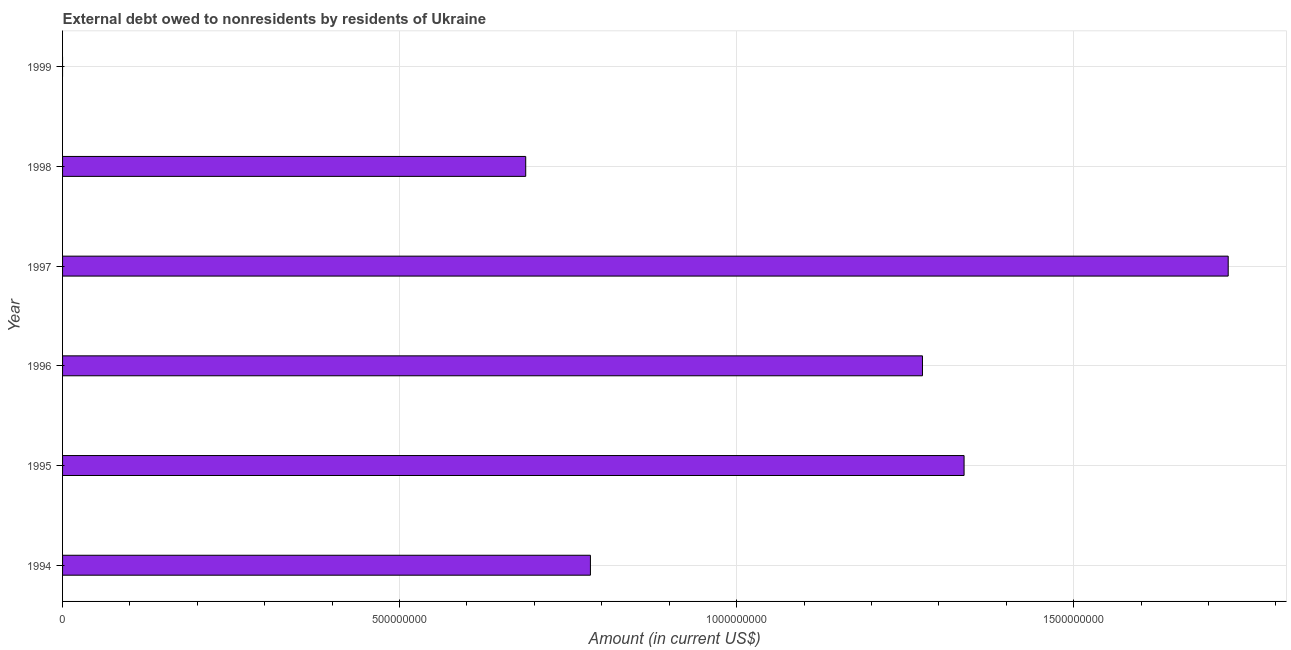What is the title of the graph?
Make the answer very short. External debt owed to nonresidents by residents of Ukraine. What is the label or title of the X-axis?
Offer a terse response. Amount (in current US$). What is the label or title of the Y-axis?
Provide a succinct answer. Year. What is the debt in 1995?
Ensure brevity in your answer.  1.34e+09. Across all years, what is the maximum debt?
Your response must be concise. 1.73e+09. In which year was the debt maximum?
Your answer should be very brief. 1997. What is the sum of the debt?
Keep it short and to the point. 5.81e+09. What is the difference between the debt in 1995 and 1996?
Your answer should be very brief. 6.17e+07. What is the average debt per year?
Offer a very short reply. 9.69e+08. What is the median debt?
Offer a very short reply. 1.03e+09. What is the ratio of the debt in 1996 to that in 1997?
Offer a very short reply. 0.74. Is the debt in 1995 less than that in 1996?
Your answer should be compact. No. What is the difference between the highest and the second highest debt?
Give a very brief answer. 3.92e+08. Is the sum of the debt in 1994 and 1998 greater than the maximum debt across all years?
Offer a terse response. No. What is the difference between the highest and the lowest debt?
Keep it short and to the point. 1.73e+09. How many bars are there?
Your answer should be compact. 5. Are all the bars in the graph horizontal?
Your response must be concise. Yes. What is the difference between two consecutive major ticks on the X-axis?
Make the answer very short. 5.00e+08. What is the Amount (in current US$) in 1994?
Your answer should be very brief. 7.83e+08. What is the Amount (in current US$) of 1995?
Ensure brevity in your answer.  1.34e+09. What is the Amount (in current US$) in 1996?
Your answer should be very brief. 1.28e+09. What is the Amount (in current US$) in 1997?
Ensure brevity in your answer.  1.73e+09. What is the Amount (in current US$) of 1998?
Give a very brief answer. 6.87e+08. What is the difference between the Amount (in current US$) in 1994 and 1995?
Your response must be concise. -5.54e+08. What is the difference between the Amount (in current US$) in 1994 and 1996?
Your response must be concise. -4.93e+08. What is the difference between the Amount (in current US$) in 1994 and 1997?
Make the answer very short. -9.46e+08. What is the difference between the Amount (in current US$) in 1994 and 1998?
Provide a succinct answer. 9.60e+07. What is the difference between the Amount (in current US$) in 1995 and 1996?
Provide a succinct answer. 6.17e+07. What is the difference between the Amount (in current US$) in 1995 and 1997?
Your response must be concise. -3.92e+08. What is the difference between the Amount (in current US$) in 1995 and 1998?
Your answer should be very brief. 6.50e+08. What is the difference between the Amount (in current US$) in 1996 and 1997?
Ensure brevity in your answer.  -4.54e+08. What is the difference between the Amount (in current US$) in 1996 and 1998?
Your response must be concise. 5.89e+08. What is the difference between the Amount (in current US$) in 1997 and 1998?
Your response must be concise. 1.04e+09. What is the ratio of the Amount (in current US$) in 1994 to that in 1995?
Make the answer very short. 0.59. What is the ratio of the Amount (in current US$) in 1994 to that in 1996?
Make the answer very short. 0.61. What is the ratio of the Amount (in current US$) in 1994 to that in 1997?
Your answer should be compact. 0.45. What is the ratio of the Amount (in current US$) in 1994 to that in 1998?
Your answer should be very brief. 1.14. What is the ratio of the Amount (in current US$) in 1995 to that in 1996?
Your answer should be compact. 1.05. What is the ratio of the Amount (in current US$) in 1995 to that in 1997?
Offer a terse response. 0.77. What is the ratio of the Amount (in current US$) in 1995 to that in 1998?
Ensure brevity in your answer.  1.95. What is the ratio of the Amount (in current US$) in 1996 to that in 1997?
Keep it short and to the point. 0.74. What is the ratio of the Amount (in current US$) in 1996 to that in 1998?
Your answer should be compact. 1.86. What is the ratio of the Amount (in current US$) in 1997 to that in 1998?
Ensure brevity in your answer.  2.52. 